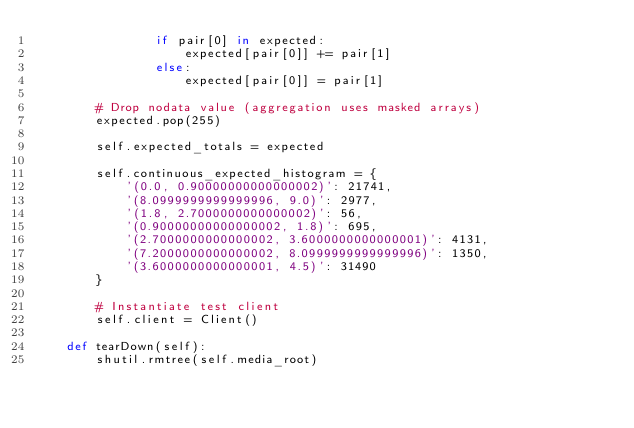Convert code to text. <code><loc_0><loc_0><loc_500><loc_500><_Python_>                if pair[0] in expected:
                    expected[pair[0]] += pair[1]
                else:
                    expected[pair[0]] = pair[1]

        # Drop nodata value (aggregation uses masked arrays)
        expected.pop(255)

        self.expected_totals = expected

        self.continuous_expected_histogram = {
            '(0.0, 0.90000000000000002)': 21741,
            '(8.0999999999999996, 9.0)': 2977,
            '(1.8, 2.7000000000000002)': 56,
            '(0.90000000000000002, 1.8)': 695,
            '(2.7000000000000002, 3.6000000000000001)': 4131,
            '(7.2000000000000002, 8.0999999999999996)': 1350,
            '(3.6000000000000001, 4.5)': 31490
        }

        # Instantiate test client
        self.client = Client()

    def tearDown(self):
        shutil.rmtree(self.media_root)
</code> 